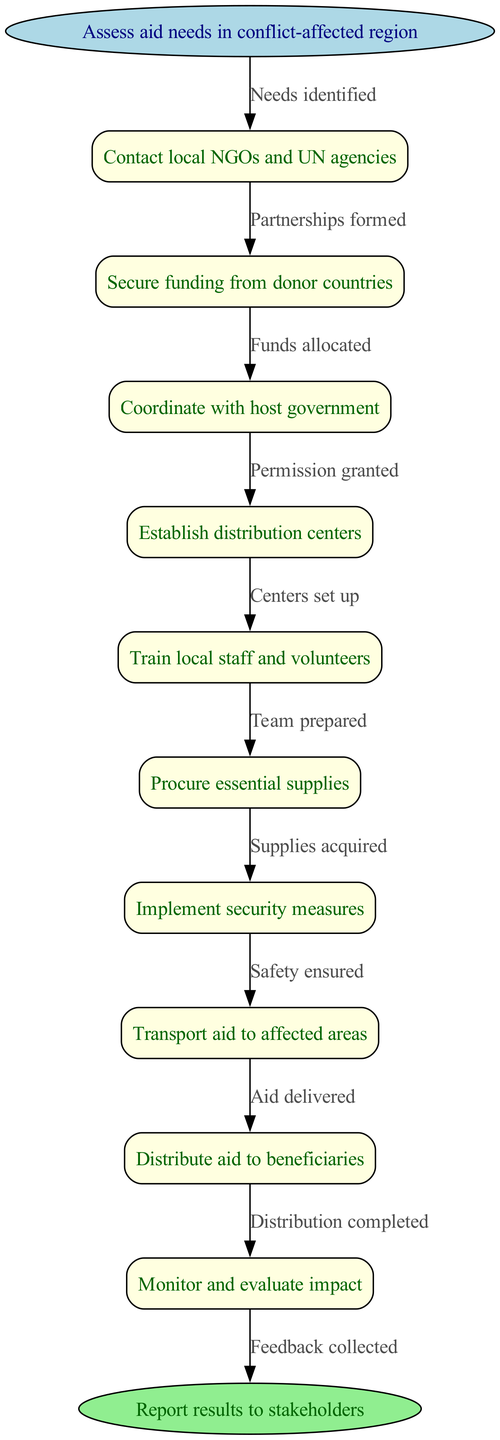What's the first step in the flowchart? The flowchart starts with the node labeled "Assess aid needs in conflict-affected region," which indicates it's the initial action taken before any further steps.
Answer: Assess aid needs in conflict-affected region How many nodes are present in the diagram? The diagram contains a total of 11 nodes, including the start and end nodes, along with the 9 intermediate nodes.
Answer: 11 What follows after "Contact local NGOs and UN agencies"? According to the flowchart, after "Contact local NGOs and UN agencies," the next step is "Secure funding from donor countries," indicating the flow of actions in the aid distribution process.
Answer: Secure funding from donor countries Which node leads to the end of the process? The final node that leads to the end of the process is "Monitor and evaluate impact," which directly connects to the end node labeled "Report results to stakeholders."
Answer: Monitor and evaluate impact What type of relationship connects "Establish distribution centers" and "Train local staff and volunteers"? The relationship is sequential; after establishing distribution centers, the next action is to train local staff and volunteers, indicating the flow of steps in aid distribution logistics.
Answer: Sequential What action occurs just before "Transport aid to affected areas"? Just before "Transport aid to affected areas," the action that occurs is "Implement security measures," which is crucial to ensuring safety in the aid transportation process.
Answer: Implement security measures How many edges are in the diagram? There are 10 edges in the diagram, representing the connections between the nodes from start to end alongside the sequence of actions.
Answer: 10 What is the purpose of the "Monitor and evaluate impact" step? The purpose of the "Monitor and evaluate impact" step is to assess the effectiveness of the aid distributed and gather feedback, which is essential for accountability and improvements in future aid efforts.
Answer: Assess effectiveness Which node is directly connected to "Secure funding from donor countries"? The node that is directly connected to "Secure funding from donor countries" is "Coordinate with host government," indicating that these steps are performed in a sequence as part of the overall process.
Answer: Coordinate with host government What measure precedes "Distribute aid to beneficiaries"? "Transport aid to affected areas" is the measure that must occur prior to "Distribute aid to beneficiaries," ensuring that the aid reaches the location where it needs to be delivered.
Answer: Transport aid to affected areas 